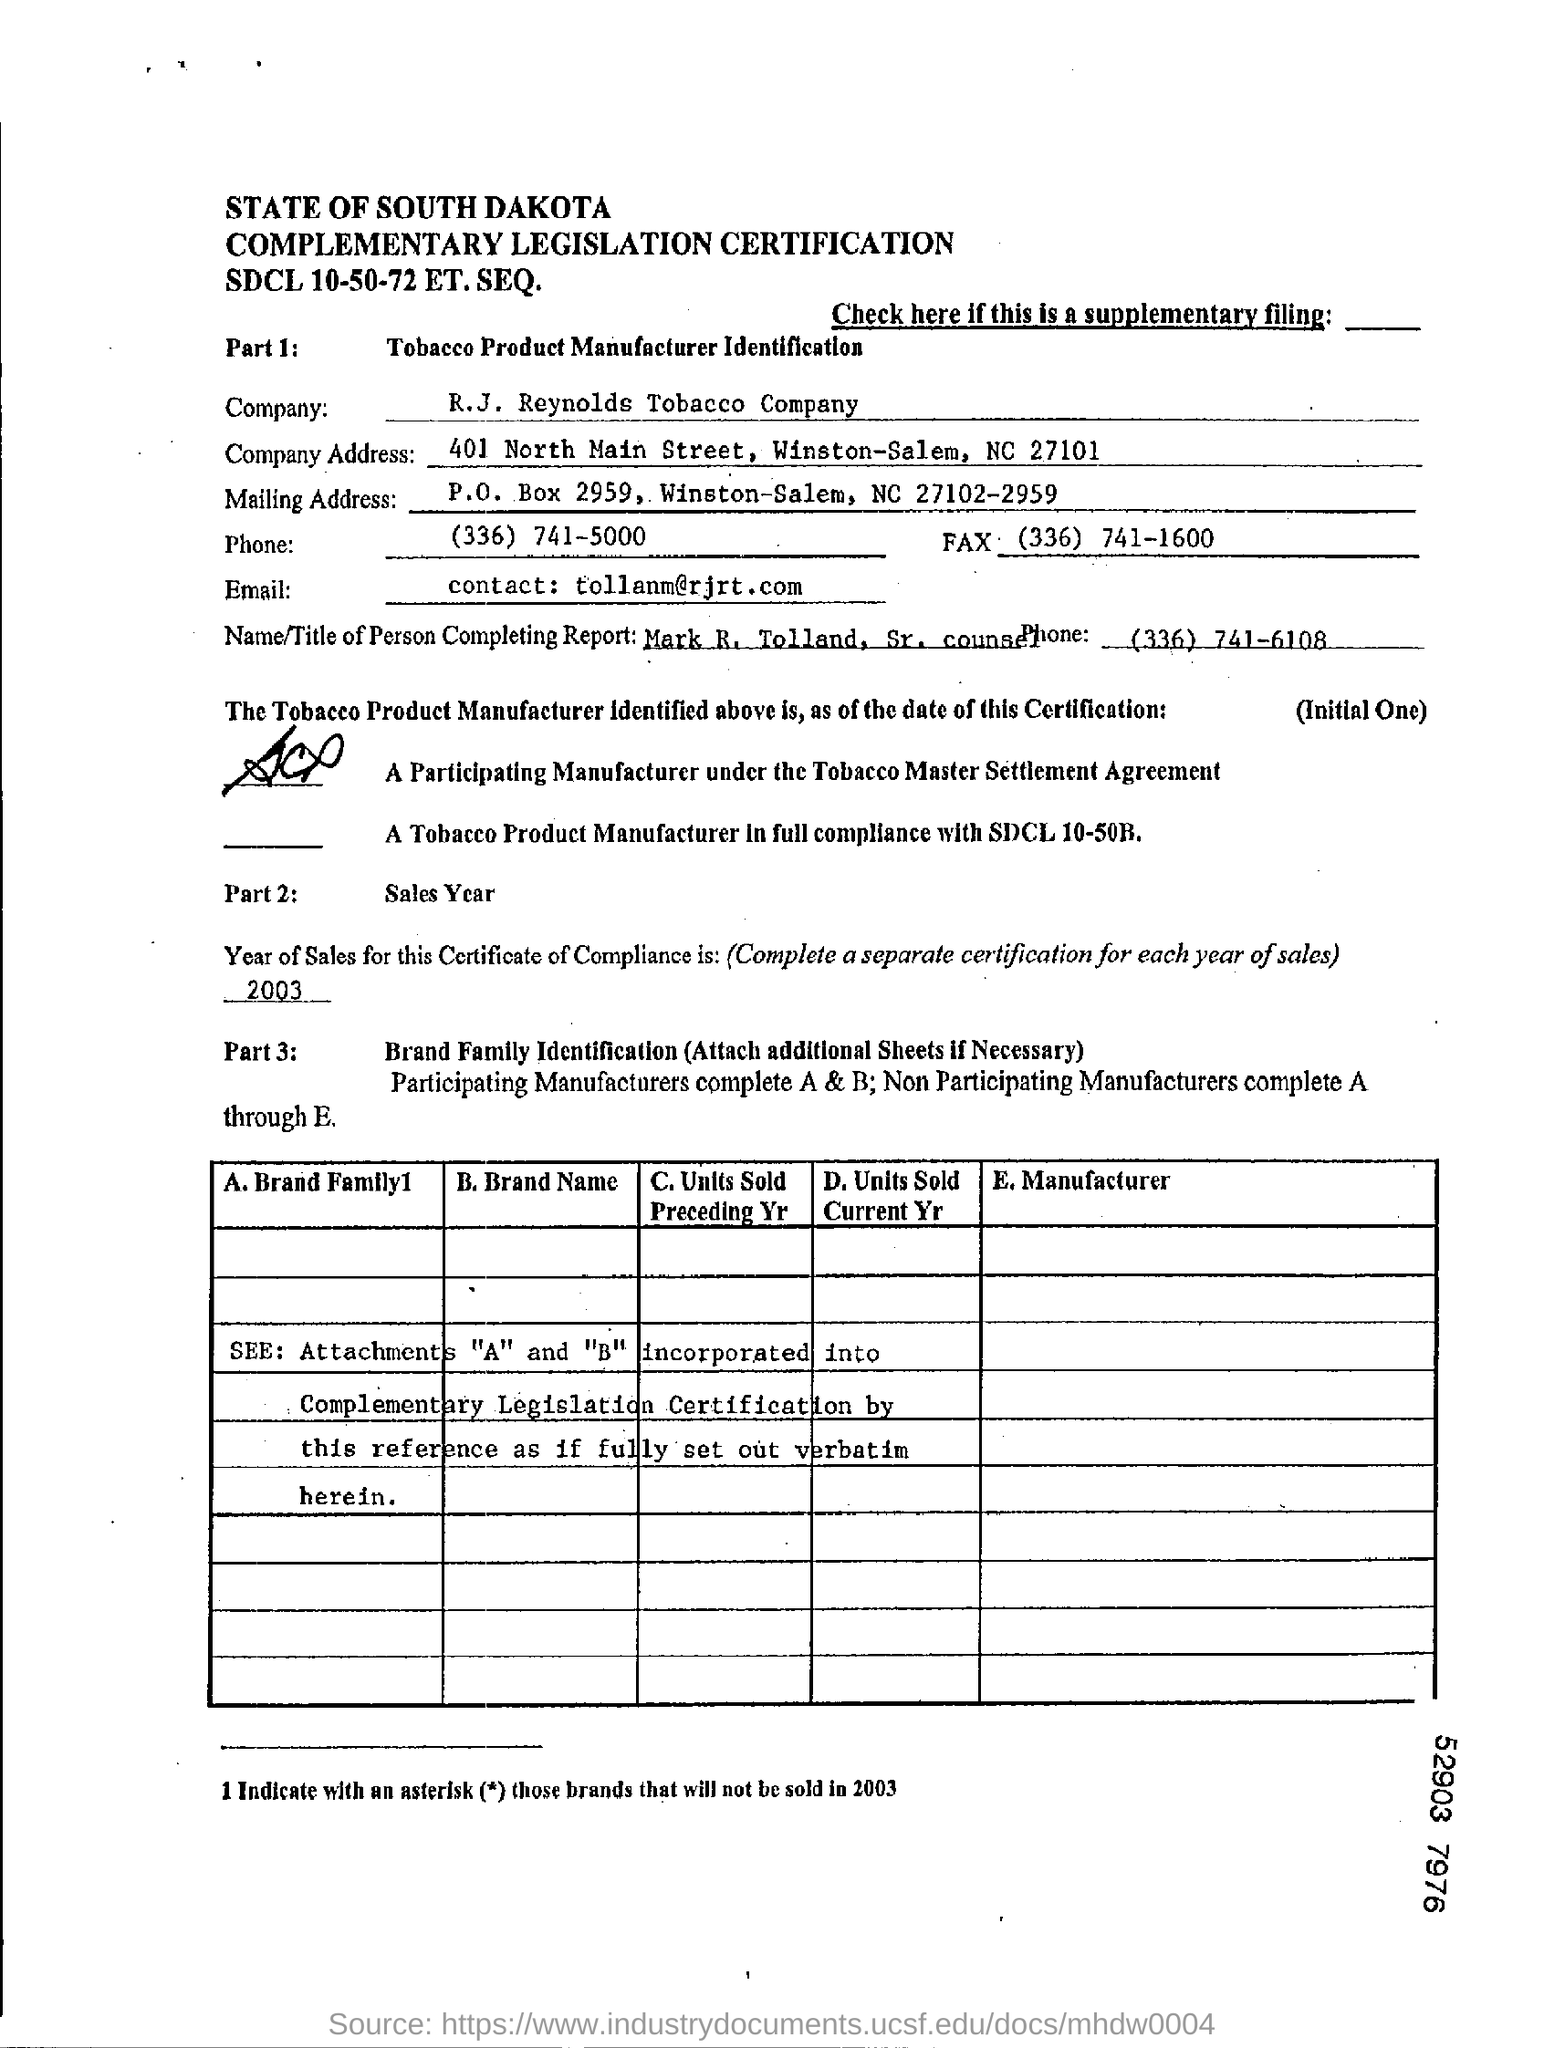Give some essential details in this illustration. The person completing the report is Mark R. Tolland, Sr. counsel. The R.J. Reynolds Tobacco Company is the name of a company. This certificate of compliance is from the year 2003. 401 North Main Street, Winston-Salem, NC 27101 is the address of the company. 